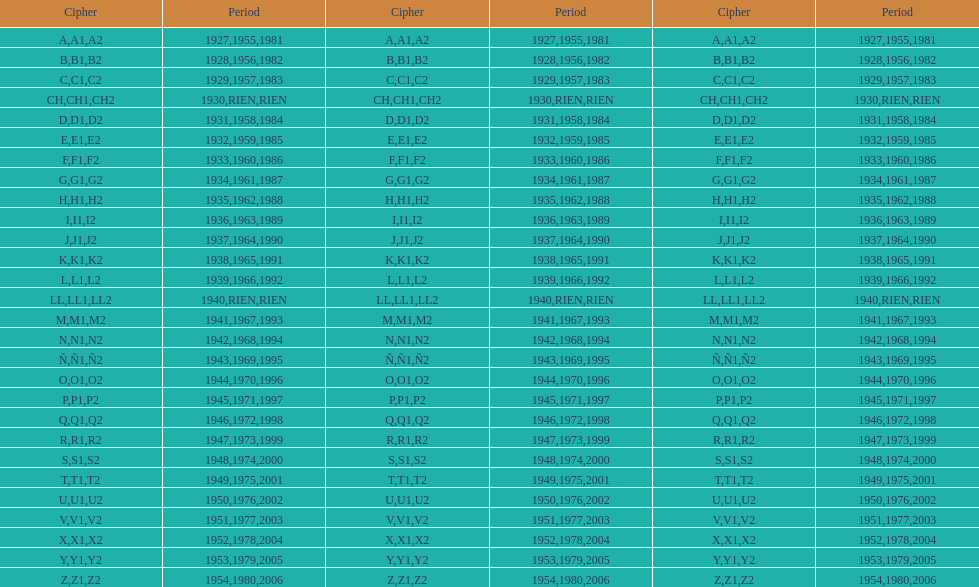Besides 1927, in which year did the code commence with an a? 1955, 1981. 